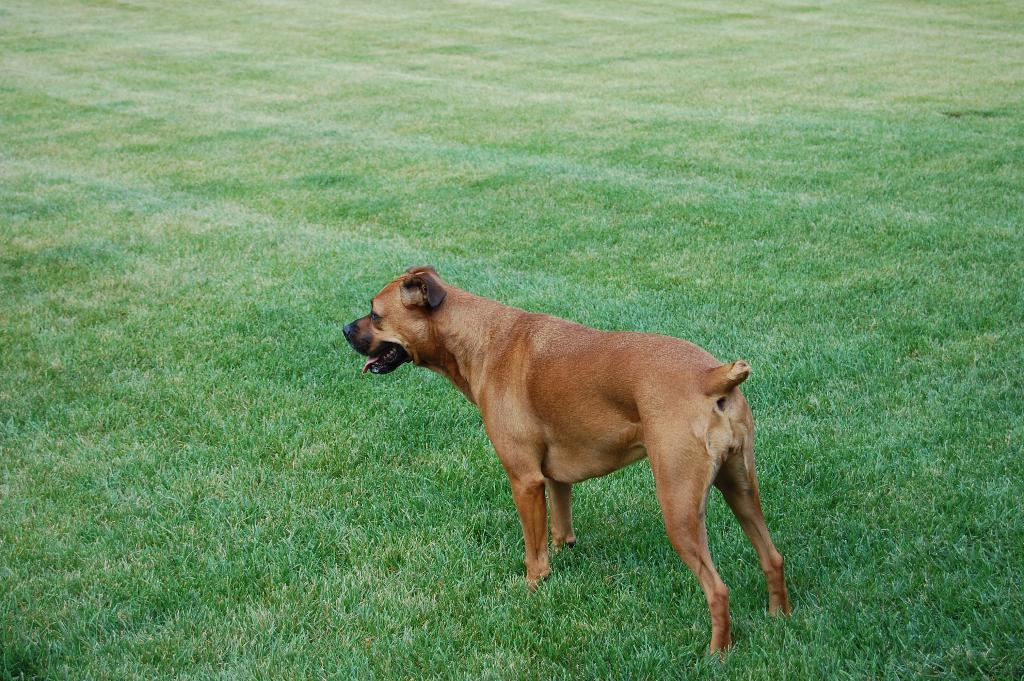What type of animal is in the image? There is a dog in the image. What colors can be seen on the dog's fur? The dog has brown and black coloring. Where is the dog located in the image? The dog is on the grass. What type of sink can be seen in the image? There is no sink present in the image; it features a dog on the grass. 